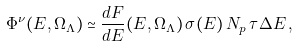<formula> <loc_0><loc_0><loc_500><loc_500>\Phi ^ { \nu } ( E , \Omega _ { \Lambda } ) \simeq \frac { d F } { d E } ( E , \Omega _ { \Lambda } ) \, \sigma ( E ) \, N _ { p } \, \tau \Delta E \, ,</formula> 